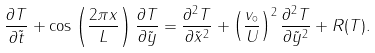Convert formula to latex. <formula><loc_0><loc_0><loc_500><loc_500>\frac { \partial T } { \partial \tilde { t } } + \cos \left ( \frac { 2 \pi x } { L } \right ) \frac { \partial T } { \partial \tilde { y } } = \frac { \partial ^ { 2 } T } { \partial \tilde { x } ^ { 2 } } + \left ( \frac { v _ { \circ } } { U } \right ) ^ { 2 } \frac { \partial ^ { 2 } T } { \partial \tilde { y } ^ { 2 } } + R ( T ) .</formula> 